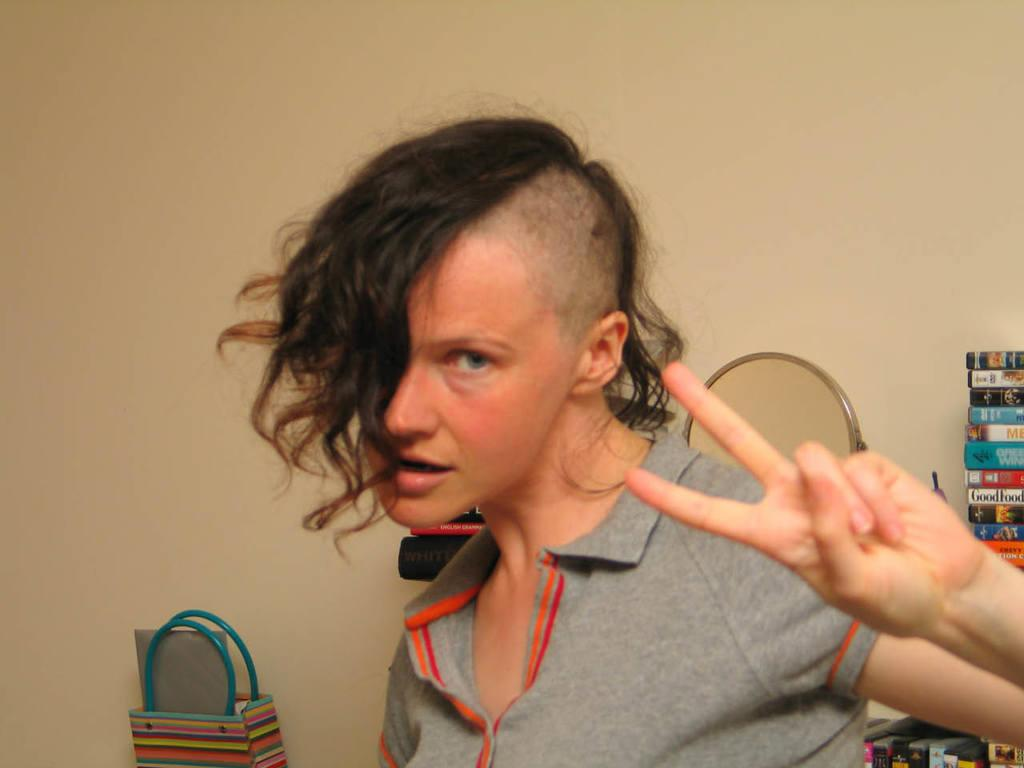What is present in the image that suggests human presence? There is a person in the image. What object can be seen that might be used for personal grooming or reflection? There is a mirror in the image. What type of items can be seen that might be used for reading or learning? There are books in the image. What type of card is being used by the person in the image? There is no card present in the image. Is there a rabbit visible in the image? There is no rabbit present in the image. 